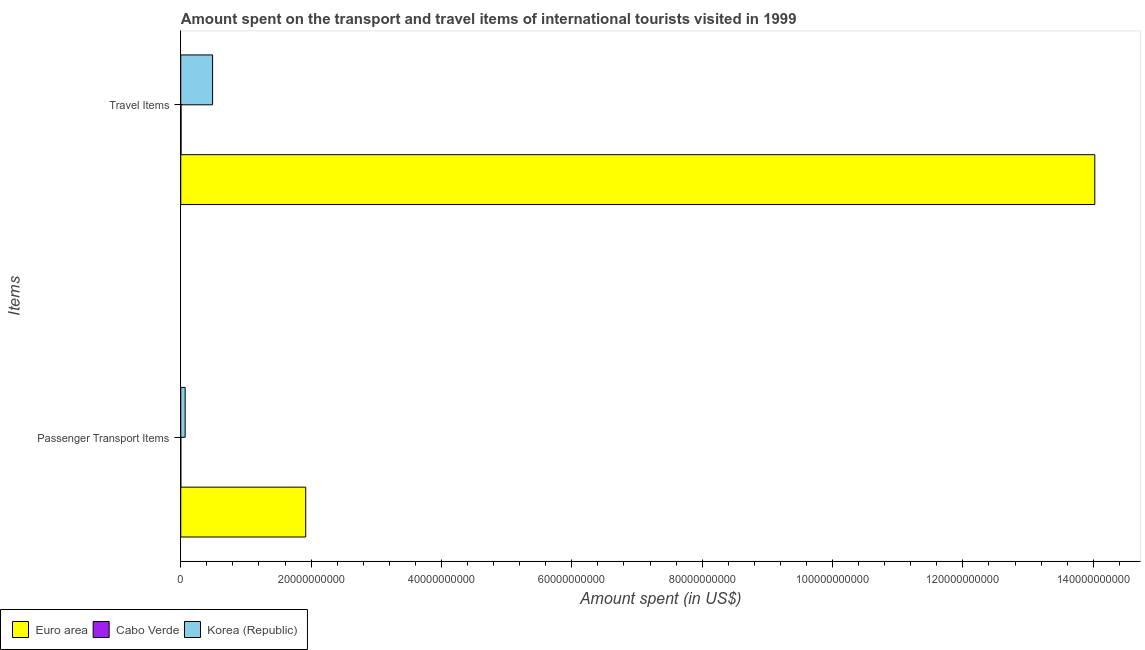Are the number of bars per tick equal to the number of legend labels?
Offer a very short reply. Yes. How many bars are there on the 1st tick from the bottom?
Your answer should be very brief. 3. What is the label of the 1st group of bars from the top?
Keep it short and to the point. Travel Items. What is the amount spent in travel items in Cabo Verde?
Make the answer very short. 4.10e+07. Across all countries, what is the maximum amount spent on passenger transport items?
Give a very brief answer. 1.92e+1. In which country was the amount spent on passenger transport items maximum?
Keep it short and to the point. Euro area. In which country was the amount spent on passenger transport items minimum?
Make the answer very short. Cabo Verde. What is the total amount spent in travel items in the graph?
Offer a very short reply. 1.45e+11. What is the difference between the amount spent in travel items in Korea (Republic) and that in Euro area?
Ensure brevity in your answer.  -1.35e+11. What is the difference between the amount spent in travel items in Korea (Republic) and the amount spent on passenger transport items in Euro area?
Your answer should be compact. -1.43e+1. What is the average amount spent in travel items per country?
Ensure brevity in your answer.  4.84e+1. What is the difference between the amount spent in travel items and amount spent on passenger transport items in Korea (Republic)?
Your response must be concise. 4.21e+09. In how many countries, is the amount spent in travel items greater than 32000000000 US$?
Give a very brief answer. 1. What is the ratio of the amount spent on passenger transport items in Euro area to that in Korea (Republic)?
Your response must be concise. 28.44. What does the 3rd bar from the top in Travel Items represents?
Offer a very short reply. Euro area. What does the 1st bar from the bottom in Passenger Transport Items represents?
Keep it short and to the point. Euro area. Are all the bars in the graph horizontal?
Ensure brevity in your answer.  Yes. Are the values on the major ticks of X-axis written in scientific E-notation?
Provide a succinct answer. No. Does the graph contain any zero values?
Keep it short and to the point. No. What is the title of the graph?
Keep it short and to the point. Amount spent on the transport and travel items of international tourists visited in 1999. Does "Jordan" appear as one of the legend labels in the graph?
Offer a very short reply. No. What is the label or title of the X-axis?
Offer a terse response. Amount spent (in US$). What is the label or title of the Y-axis?
Ensure brevity in your answer.  Items. What is the Amount spent (in US$) of Euro area in Passenger Transport Items?
Your response must be concise. 1.92e+1. What is the Amount spent (in US$) of Cabo Verde in Passenger Transport Items?
Your answer should be compact. 6.00e+06. What is the Amount spent (in US$) of Korea (Republic) in Passenger Transport Items?
Make the answer very short. 6.74e+08. What is the Amount spent (in US$) in Euro area in Travel Items?
Offer a terse response. 1.40e+11. What is the Amount spent (in US$) of Cabo Verde in Travel Items?
Your answer should be compact. 4.10e+07. What is the Amount spent (in US$) of Korea (Republic) in Travel Items?
Give a very brief answer. 4.88e+09. Across all Items, what is the maximum Amount spent (in US$) of Euro area?
Provide a succinct answer. 1.40e+11. Across all Items, what is the maximum Amount spent (in US$) in Cabo Verde?
Provide a short and direct response. 4.10e+07. Across all Items, what is the maximum Amount spent (in US$) in Korea (Republic)?
Ensure brevity in your answer.  4.88e+09. Across all Items, what is the minimum Amount spent (in US$) in Euro area?
Give a very brief answer. 1.92e+1. Across all Items, what is the minimum Amount spent (in US$) in Korea (Republic)?
Make the answer very short. 6.74e+08. What is the total Amount spent (in US$) of Euro area in the graph?
Offer a terse response. 1.59e+11. What is the total Amount spent (in US$) of Cabo Verde in the graph?
Your response must be concise. 4.70e+07. What is the total Amount spent (in US$) in Korea (Republic) in the graph?
Offer a very short reply. 5.56e+09. What is the difference between the Amount spent (in US$) of Euro area in Passenger Transport Items and that in Travel Items?
Your response must be concise. -1.21e+11. What is the difference between the Amount spent (in US$) in Cabo Verde in Passenger Transport Items and that in Travel Items?
Your response must be concise. -3.50e+07. What is the difference between the Amount spent (in US$) in Korea (Republic) in Passenger Transport Items and that in Travel Items?
Offer a terse response. -4.21e+09. What is the difference between the Amount spent (in US$) in Euro area in Passenger Transport Items and the Amount spent (in US$) in Cabo Verde in Travel Items?
Your response must be concise. 1.91e+1. What is the difference between the Amount spent (in US$) in Euro area in Passenger Transport Items and the Amount spent (in US$) in Korea (Republic) in Travel Items?
Offer a very short reply. 1.43e+1. What is the difference between the Amount spent (in US$) of Cabo Verde in Passenger Transport Items and the Amount spent (in US$) of Korea (Republic) in Travel Items?
Make the answer very short. -4.88e+09. What is the average Amount spent (in US$) of Euro area per Items?
Give a very brief answer. 7.97e+1. What is the average Amount spent (in US$) in Cabo Verde per Items?
Give a very brief answer. 2.35e+07. What is the average Amount spent (in US$) in Korea (Republic) per Items?
Keep it short and to the point. 2.78e+09. What is the difference between the Amount spent (in US$) in Euro area and Amount spent (in US$) in Cabo Verde in Passenger Transport Items?
Offer a very short reply. 1.92e+1. What is the difference between the Amount spent (in US$) in Euro area and Amount spent (in US$) in Korea (Republic) in Passenger Transport Items?
Provide a succinct answer. 1.85e+1. What is the difference between the Amount spent (in US$) of Cabo Verde and Amount spent (in US$) of Korea (Republic) in Passenger Transport Items?
Provide a succinct answer. -6.68e+08. What is the difference between the Amount spent (in US$) of Euro area and Amount spent (in US$) of Cabo Verde in Travel Items?
Offer a terse response. 1.40e+11. What is the difference between the Amount spent (in US$) in Euro area and Amount spent (in US$) in Korea (Republic) in Travel Items?
Ensure brevity in your answer.  1.35e+11. What is the difference between the Amount spent (in US$) in Cabo Verde and Amount spent (in US$) in Korea (Republic) in Travel Items?
Provide a short and direct response. -4.84e+09. What is the ratio of the Amount spent (in US$) in Euro area in Passenger Transport Items to that in Travel Items?
Your answer should be very brief. 0.14. What is the ratio of the Amount spent (in US$) in Cabo Verde in Passenger Transport Items to that in Travel Items?
Ensure brevity in your answer.  0.15. What is the ratio of the Amount spent (in US$) of Korea (Republic) in Passenger Transport Items to that in Travel Items?
Offer a terse response. 0.14. What is the difference between the highest and the second highest Amount spent (in US$) in Euro area?
Provide a succinct answer. 1.21e+11. What is the difference between the highest and the second highest Amount spent (in US$) of Cabo Verde?
Give a very brief answer. 3.50e+07. What is the difference between the highest and the second highest Amount spent (in US$) in Korea (Republic)?
Offer a very short reply. 4.21e+09. What is the difference between the highest and the lowest Amount spent (in US$) in Euro area?
Ensure brevity in your answer.  1.21e+11. What is the difference between the highest and the lowest Amount spent (in US$) in Cabo Verde?
Ensure brevity in your answer.  3.50e+07. What is the difference between the highest and the lowest Amount spent (in US$) in Korea (Republic)?
Ensure brevity in your answer.  4.21e+09. 